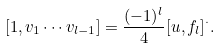Convert formula to latex. <formula><loc_0><loc_0><loc_500><loc_500>[ 1 , v _ { 1 } \cdots v _ { l - 1 } ] = \frac { ( - 1 ) ^ { l } } { 4 } [ u , f _ { l } ] ^ { \cdot } .</formula> 